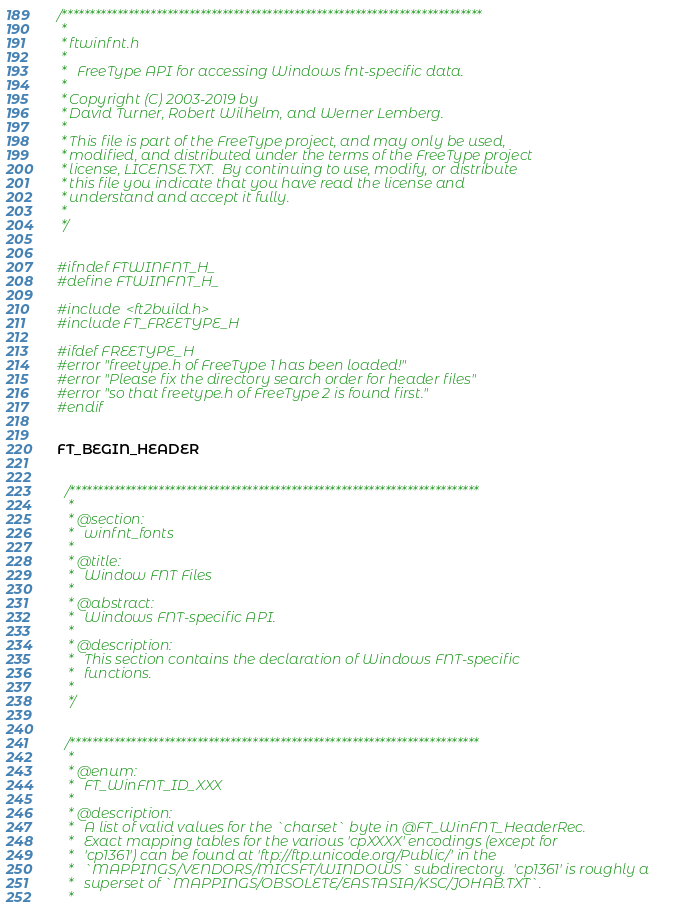<code> <loc_0><loc_0><loc_500><loc_500><_C_>/****************************************************************************
 *
 * ftwinfnt.h
 *
 *   FreeType API for accessing Windows fnt-specific data.
 *
 * Copyright (C) 2003-2019 by
 * David Turner, Robert Wilhelm, and Werner Lemberg.
 *
 * This file is part of the FreeType project, and may only be used,
 * modified, and distributed under the terms of the FreeType project
 * license, LICENSE.TXT.  By continuing to use, modify, or distribute
 * this file you indicate that you have read the license and
 * understand and accept it fully.
 *
 */


#ifndef FTWINFNT_H_
#define FTWINFNT_H_

#include <ft2build.h>
#include FT_FREETYPE_H

#ifdef FREETYPE_H
#error "freetype.h of FreeType 1 has been loaded!"
#error "Please fix the directory search order for header files"
#error "so that freetype.h of FreeType 2 is found first."
#endif


FT_BEGIN_HEADER


  /**************************************************************************
   *
   * @section:
   *   winfnt_fonts
   *
   * @title:
   *   Window FNT Files
   *
   * @abstract:
   *   Windows FNT-specific API.
   *
   * @description:
   *   This section contains the declaration of Windows FNT-specific
   *   functions.
   *
   */


  /**************************************************************************
   *
   * @enum:
   *   FT_WinFNT_ID_XXX
   *
   * @description:
   *   A list of valid values for the `charset` byte in @FT_WinFNT_HeaderRec. 
   *   Exact mapping tables for the various 'cpXXXX' encodings (except for
   *   'cp1361') can be found at 'ftp://ftp.unicode.org/Public/' in the
   *   `MAPPINGS/VENDORS/MICSFT/WINDOWS` subdirectory.  'cp1361' is roughly a
   *   superset of `MAPPINGS/OBSOLETE/EASTASIA/KSC/JOHAB.TXT`.
   *</code> 